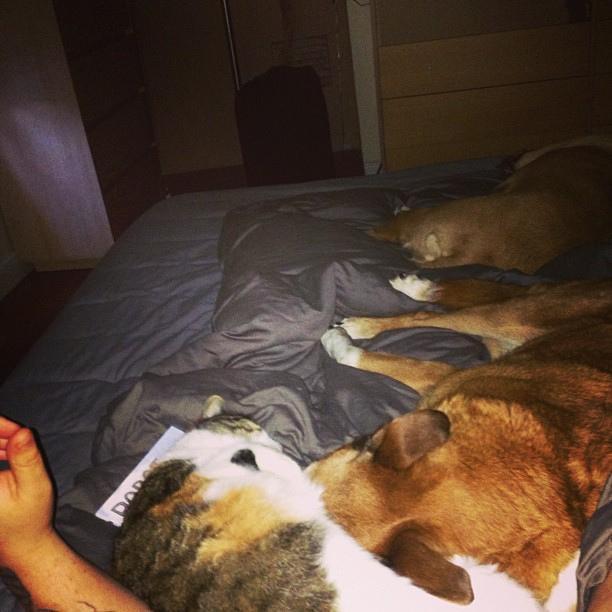The cat is cozying up to what animal?
Answer the question by selecting the correct answer among the 4 following choices.
Options: Pig, cow, dog, goat. Dog. 